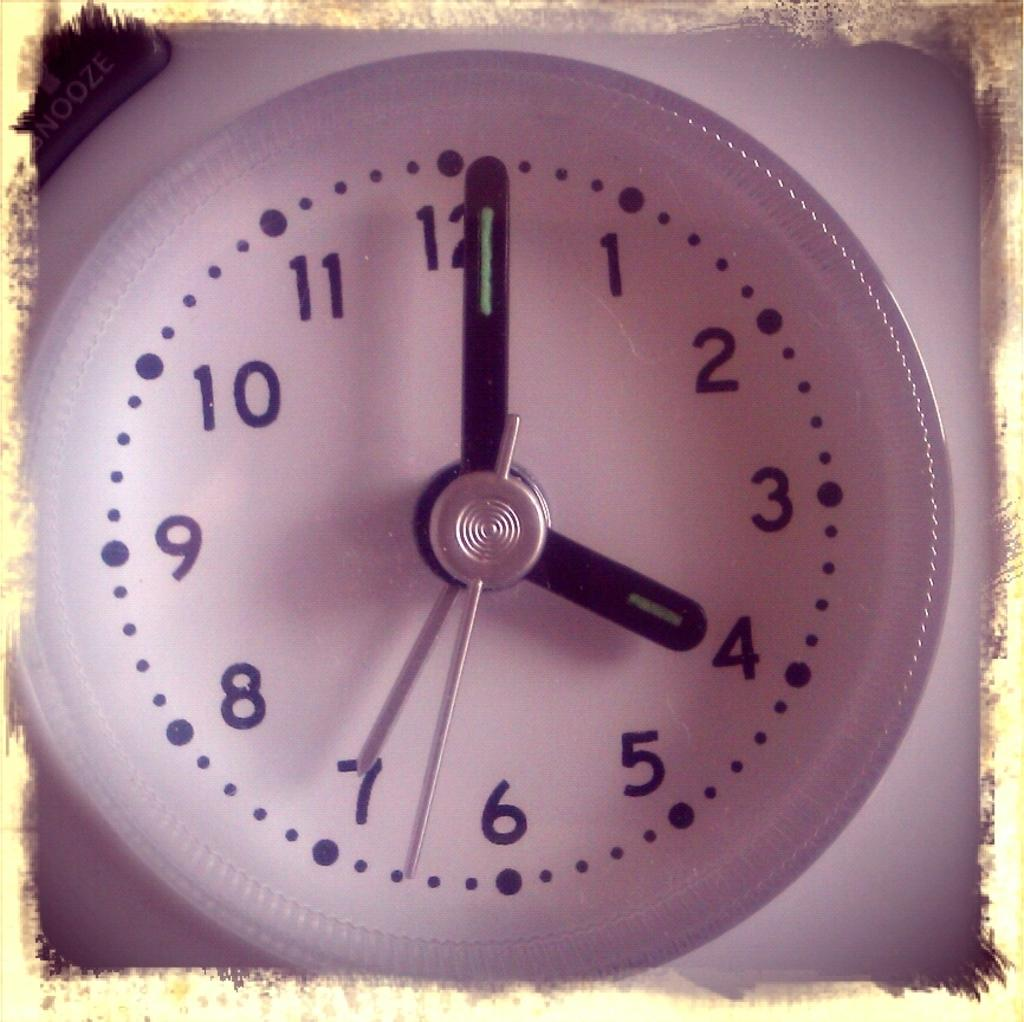<image>
Render a clear and concise summary of the photo. A clock displaying a time of 4:01 with a snooze button 